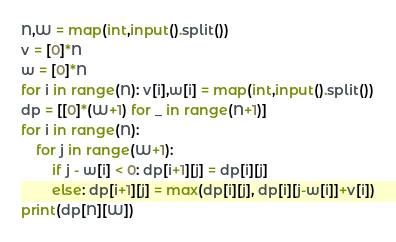Convert code to text. <code><loc_0><loc_0><loc_500><loc_500><_Python_>N,W = map(int,input().split())
v = [0]*N
w = [0]*N
for i in range(N): v[i],w[i] = map(int,input().split())
dp = [[0]*(W+1) for _ in range(N+1)]
for i in range(N):
    for j in range(W+1):
        if j - w[i] < 0: dp[i+1][j] = dp[i][j]
        else: dp[i+1][j] = max(dp[i][j], dp[i][j-w[i]]+v[i])
print(dp[N][W])
</code> 